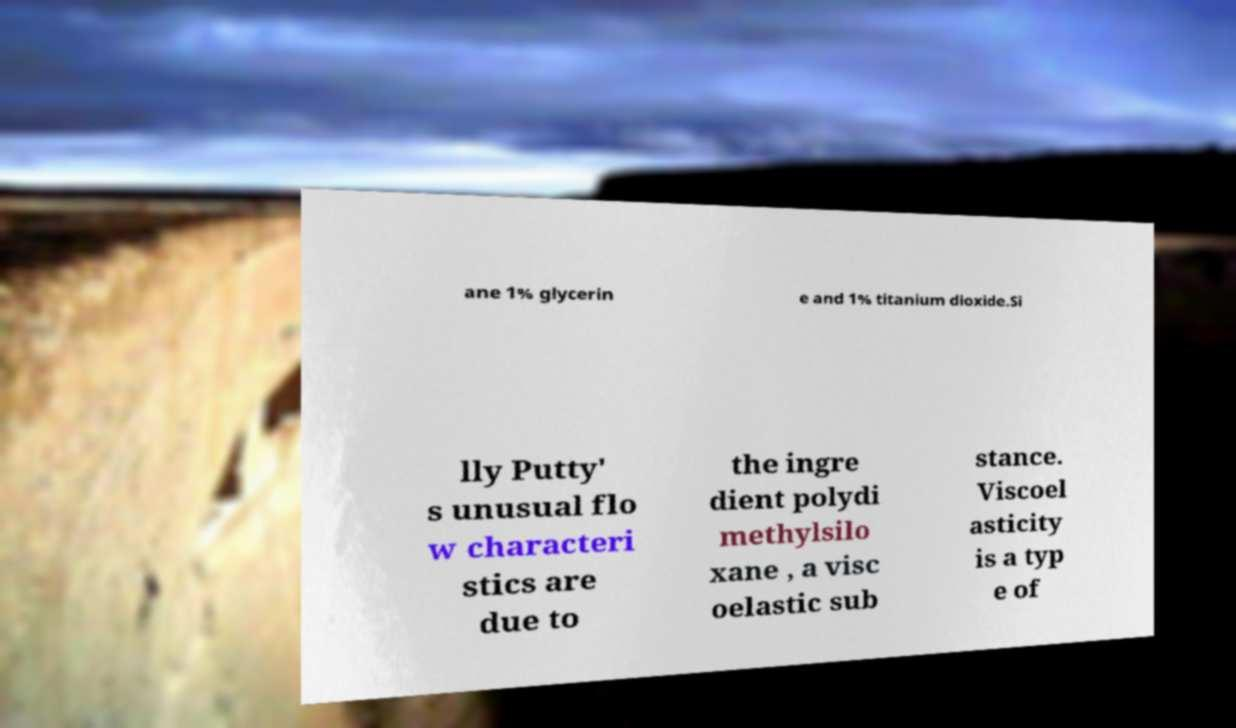Can you accurately transcribe the text from the provided image for me? ane 1% glycerin e and 1% titanium dioxide.Si lly Putty' s unusual flo w characteri stics are due to the ingre dient polydi methylsilo xane , a visc oelastic sub stance. Viscoel asticity is a typ e of 